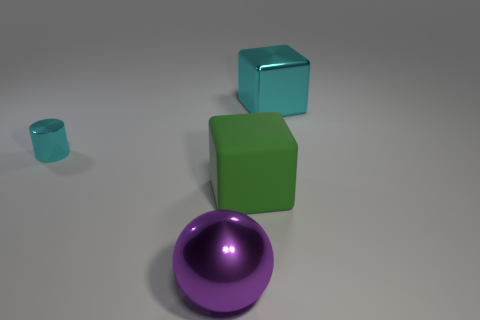What number of other things are the same color as the small thing?
Provide a succinct answer. 1. What shape is the large metal object to the left of the big metallic thing that is to the right of the large green cube?
Provide a succinct answer. Sphere. Is there anything else that has the same shape as the tiny cyan metal thing?
Provide a succinct answer. No. Is the number of green things left of the metal cylinder greater than the number of big purple metallic things?
Provide a succinct answer. No. There is a cyan metallic object that is behind the metal cylinder; how many things are in front of it?
Your response must be concise. 3. What shape is the cyan thing that is on the left side of the matte thing in front of the cyan object that is on the right side of the cyan metallic cylinder?
Provide a succinct answer. Cylinder. What is the size of the cyan cylinder?
Keep it short and to the point. Small. Is there a cyan cube that has the same material as the tiny cylinder?
Offer a terse response. Yes. There is a cyan thing that is the same shape as the large green matte object; what is its size?
Your response must be concise. Large. Are there the same number of big green things that are to the left of the large matte cube and small red rubber cubes?
Your answer should be very brief. Yes. 